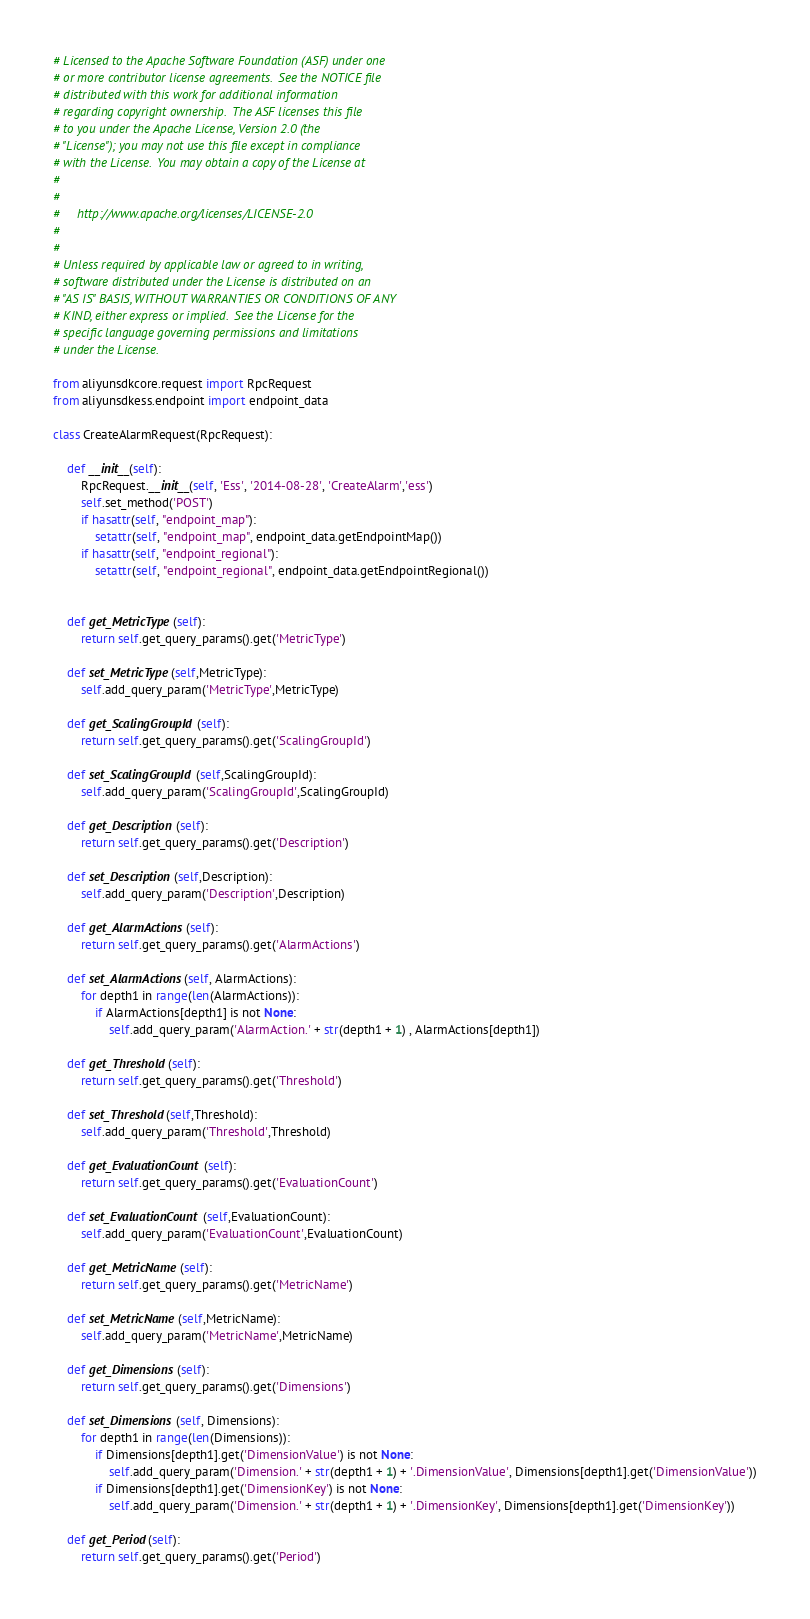<code> <loc_0><loc_0><loc_500><loc_500><_Python_># Licensed to the Apache Software Foundation (ASF) under one
# or more contributor license agreements.  See the NOTICE file
# distributed with this work for additional information
# regarding copyright ownership.  The ASF licenses this file
# to you under the Apache License, Version 2.0 (the
# "License"); you may not use this file except in compliance
# with the License.  You may obtain a copy of the License at
#
#
#     http://www.apache.org/licenses/LICENSE-2.0
#
#
# Unless required by applicable law or agreed to in writing,
# software distributed under the License is distributed on an
# "AS IS" BASIS, WITHOUT WARRANTIES OR CONDITIONS OF ANY
# KIND, either express or implied.  See the License for the
# specific language governing permissions and limitations
# under the License.

from aliyunsdkcore.request import RpcRequest
from aliyunsdkess.endpoint import endpoint_data

class CreateAlarmRequest(RpcRequest):

	def __init__(self):
		RpcRequest.__init__(self, 'Ess', '2014-08-28', 'CreateAlarm','ess')
		self.set_method('POST')
		if hasattr(self, "endpoint_map"):
			setattr(self, "endpoint_map", endpoint_data.getEndpointMap())
		if hasattr(self, "endpoint_regional"):
			setattr(self, "endpoint_regional", endpoint_data.getEndpointRegional())


	def get_MetricType(self):
		return self.get_query_params().get('MetricType')

	def set_MetricType(self,MetricType):
		self.add_query_param('MetricType',MetricType)

	def get_ScalingGroupId(self):
		return self.get_query_params().get('ScalingGroupId')

	def set_ScalingGroupId(self,ScalingGroupId):
		self.add_query_param('ScalingGroupId',ScalingGroupId)

	def get_Description(self):
		return self.get_query_params().get('Description')

	def set_Description(self,Description):
		self.add_query_param('Description',Description)

	def get_AlarmActions(self):
		return self.get_query_params().get('AlarmActions')

	def set_AlarmActions(self, AlarmActions):
		for depth1 in range(len(AlarmActions)):
			if AlarmActions[depth1] is not None:
				self.add_query_param('AlarmAction.' + str(depth1 + 1) , AlarmActions[depth1])

	def get_Threshold(self):
		return self.get_query_params().get('Threshold')

	def set_Threshold(self,Threshold):
		self.add_query_param('Threshold',Threshold)

	def get_EvaluationCount(self):
		return self.get_query_params().get('EvaluationCount')

	def set_EvaluationCount(self,EvaluationCount):
		self.add_query_param('EvaluationCount',EvaluationCount)

	def get_MetricName(self):
		return self.get_query_params().get('MetricName')

	def set_MetricName(self,MetricName):
		self.add_query_param('MetricName',MetricName)

	def get_Dimensions(self):
		return self.get_query_params().get('Dimensions')

	def set_Dimensions(self, Dimensions):
		for depth1 in range(len(Dimensions)):
			if Dimensions[depth1].get('DimensionValue') is not None:
				self.add_query_param('Dimension.' + str(depth1 + 1) + '.DimensionValue', Dimensions[depth1].get('DimensionValue'))
			if Dimensions[depth1].get('DimensionKey') is not None:
				self.add_query_param('Dimension.' + str(depth1 + 1) + '.DimensionKey', Dimensions[depth1].get('DimensionKey'))

	def get_Period(self):
		return self.get_query_params().get('Period')
</code> 